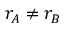<formula> <loc_0><loc_0><loc_500><loc_500>r _ { A } \neq r _ { B }</formula> 